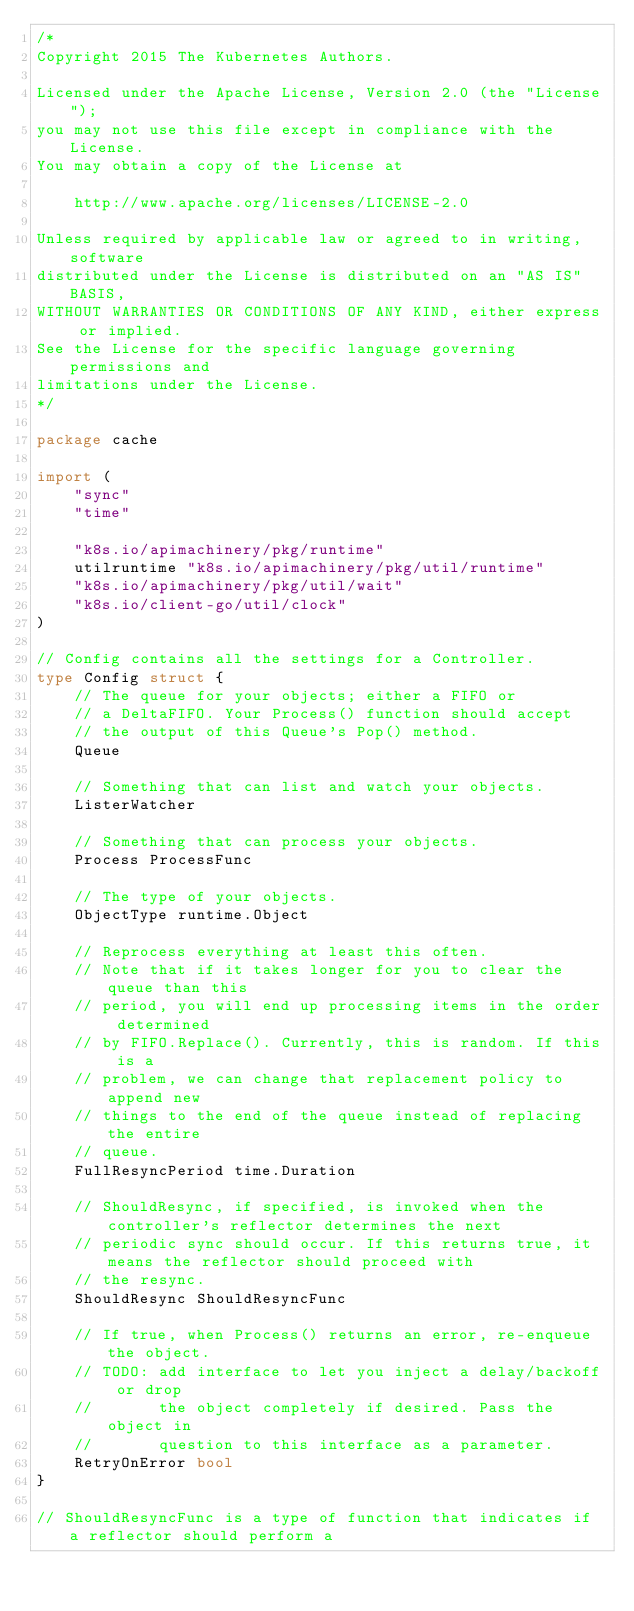<code> <loc_0><loc_0><loc_500><loc_500><_Go_>/*
Copyright 2015 The Kubernetes Authors.

Licensed under the Apache License, Version 2.0 (the "License");
you may not use this file except in compliance with the License.
You may obtain a copy of the License at

    http://www.apache.org/licenses/LICENSE-2.0

Unless required by applicable law or agreed to in writing, software
distributed under the License is distributed on an "AS IS" BASIS,
WITHOUT WARRANTIES OR CONDITIONS OF ANY KIND, either express or implied.
See the License for the specific language governing permissions and
limitations under the License.
*/

package cache

import (
	"sync"
	"time"

	"k8s.io/apimachinery/pkg/runtime"
	utilruntime "k8s.io/apimachinery/pkg/util/runtime"
	"k8s.io/apimachinery/pkg/util/wait"
	"k8s.io/client-go/util/clock"
)

// Config contains all the settings for a Controller.
type Config struct {
	// The queue for your objects; either a FIFO or
	// a DeltaFIFO. Your Process() function should accept
	// the output of this Queue's Pop() method.
	Queue

	// Something that can list and watch your objects.
	ListerWatcher

	// Something that can process your objects.
	Process ProcessFunc

	// The type of your objects.
	ObjectType runtime.Object

	// Reprocess everything at least this often.
	// Note that if it takes longer for you to clear the queue than this
	// period, you will end up processing items in the order determined
	// by FIFO.Replace(). Currently, this is random. If this is a
	// problem, we can change that replacement policy to append new
	// things to the end of the queue instead of replacing the entire
	// queue.
	FullResyncPeriod time.Duration

	// ShouldResync, if specified, is invoked when the controller's reflector determines the next
	// periodic sync should occur. If this returns true, it means the reflector should proceed with
	// the resync.
	ShouldResync ShouldResyncFunc

	// If true, when Process() returns an error, re-enqueue the object.
	// TODO: add interface to let you inject a delay/backoff or drop
	//       the object completely if desired. Pass the object in
	//       question to this interface as a parameter.
	RetryOnError bool
}

// ShouldResyncFunc is a type of function that indicates if a reflector should perform a</code> 